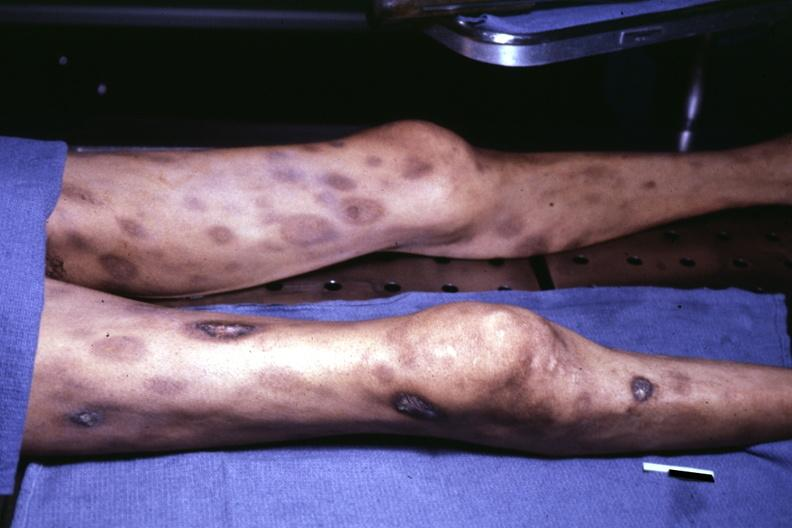what looks like pyoderma gangrenosum?
Answer the question using a single word or phrase. Ulceration 